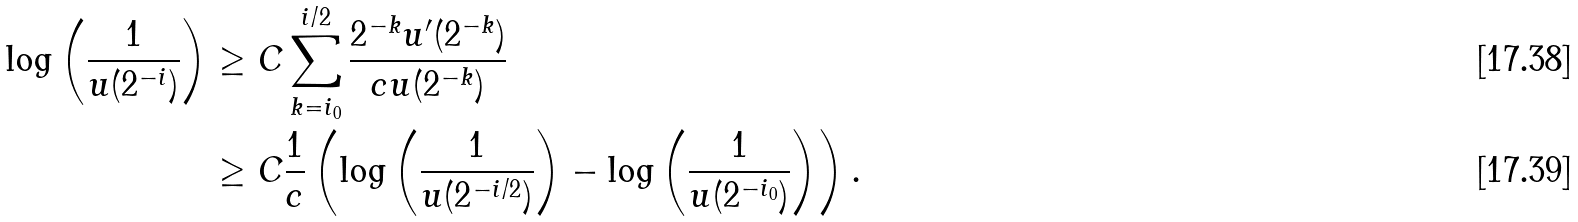<formula> <loc_0><loc_0><loc_500><loc_500>\log \left ( \frac { 1 } { u ( 2 ^ { - i } ) } \right ) & \geq C \sum _ { k = i _ { 0 } } ^ { i / 2 } \frac { 2 ^ { - k } u ^ { \prime } ( 2 ^ { - k } ) } { c u ( 2 ^ { - k } ) } \\ & \geq C \frac { 1 } { c } \left ( \log \left ( \frac { 1 } { u ( 2 ^ { - i / 2 } ) } \right ) - \log \left ( \frac { 1 } { u ( 2 ^ { - i _ { 0 } } ) } \right ) \right ) .</formula> 